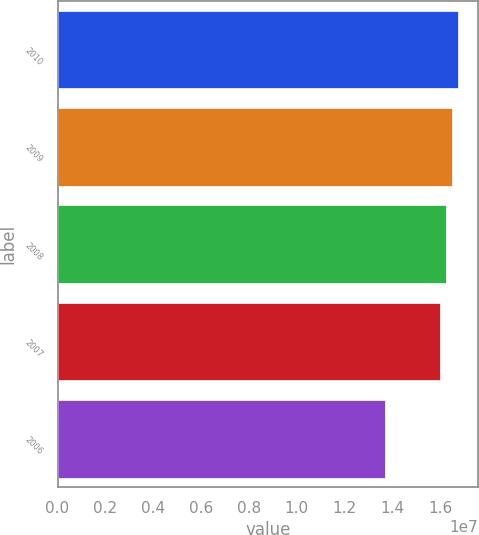Convert chart to OTSL. <chart><loc_0><loc_0><loc_500><loc_500><bar_chart><fcel>2010<fcel>2009<fcel>2008<fcel>2007<fcel>2006<nl><fcel>1.67446e+07<fcel>1.64944e+07<fcel>1.62442e+07<fcel>1.5994e+07<fcel>1.3692e+07<nl></chart> 